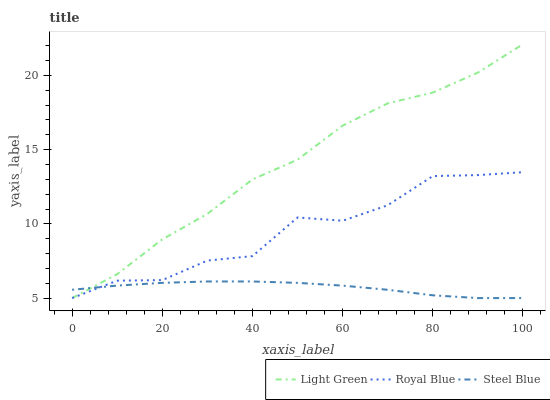Does Steel Blue have the minimum area under the curve?
Answer yes or no. Yes. Does Light Green have the maximum area under the curve?
Answer yes or no. Yes. Does Light Green have the minimum area under the curve?
Answer yes or no. No. Does Steel Blue have the maximum area under the curve?
Answer yes or no. No. Is Steel Blue the smoothest?
Answer yes or no. Yes. Is Royal Blue the roughest?
Answer yes or no. Yes. Is Light Green the smoothest?
Answer yes or no. No. Is Light Green the roughest?
Answer yes or no. No. Does Royal Blue have the lowest value?
Answer yes or no. Yes. Does Light Green have the highest value?
Answer yes or no. Yes. Does Steel Blue have the highest value?
Answer yes or no. No. Does Steel Blue intersect Royal Blue?
Answer yes or no. Yes. Is Steel Blue less than Royal Blue?
Answer yes or no. No. Is Steel Blue greater than Royal Blue?
Answer yes or no. No. 